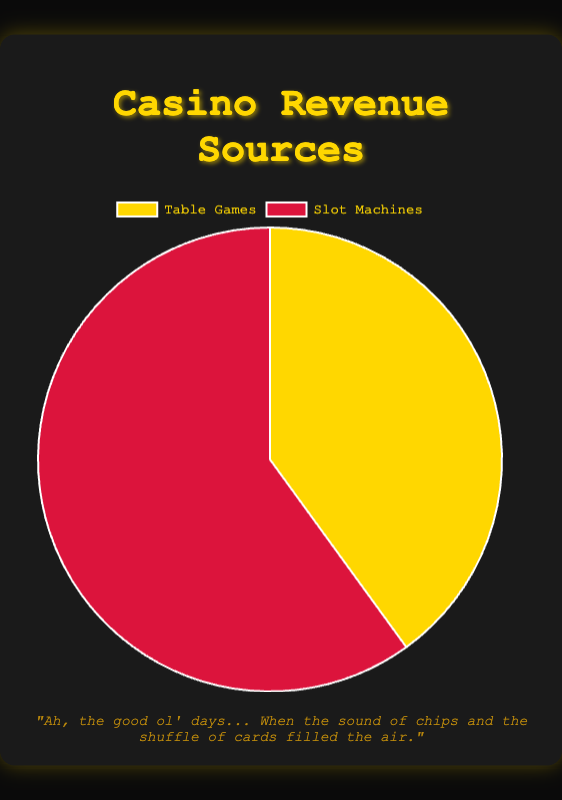What's the percentage of revenue generated by table games? By looking at the pie chart, you can see that table games contribute 40% to the revenue.
Answer: 40% Which source generates more revenue, table games or slot machines? Slot machines generate more revenue compared to table games, as indicated by the larger section of the pie chart representing slot machines at 60%.
Answer: Slot machines What is the difference in revenue percentage between slot machines and table games? Slot machines generate 60% while table games generate 40%. The difference in revenue percentage is 60% - 40%.
Answer: 20% Which source is represented by the red color in the chart? The chart shows slot machines in red.
Answer: Slot machines Calculate the total revenue percentage for both sources combined. The chart represents two sources: table games at 40% and slot machines at 60%. Adding them together gives 40% + 60%.
Answer: 100% If the revenue percentages for table games and slot machines were swapped, how would the chart look? If swapped, table games would be 60% and slot machines would be 40%. The yellow section (table games) would be larger and the red section (slot machines) smaller.
Answer: Table games 60%, Slot machines 40% Compared to weekdays, when is the revenue from table games likely to be higher? Based on the provided details, revenue from table games is higher on weekends and holidays.
Answer: Weekends and holidays What demographic is most likely contributing to slot machine revenue? The details indicate that seniors and solo players are the primary demographics for slot machines.
Answer: Seniors and solo players 